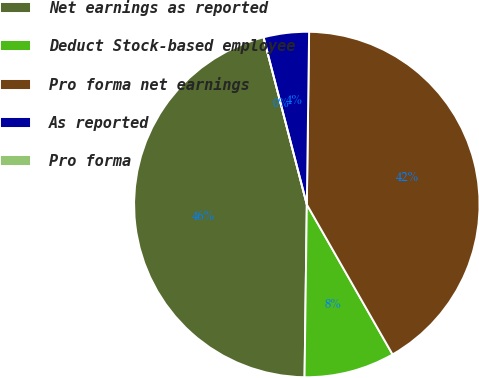Convert chart. <chart><loc_0><loc_0><loc_500><loc_500><pie_chart><fcel>Net earnings as reported<fcel>Deduct Stock-based employee<fcel>Pro forma net earnings<fcel>As reported<fcel>Pro forma<nl><fcel>45.76%<fcel>8.48%<fcel>41.52%<fcel>4.24%<fcel>0.0%<nl></chart> 